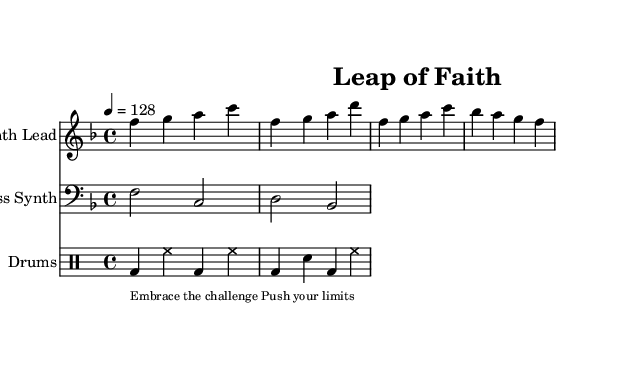What is the key signature of this piece? The key signature is F major, which has one flat (B flat).
Answer: F major What is the time signature used in this sheet music? The time signature is indicated at the beginning of the score as 4/4, meaning there are four beats per measure.
Answer: 4/4 What is the tempo marking for the composition? The tempo marking is found at the start with the indication "4 = 128", which instructs the performer to play at a speed of 128 beats per minute.
Answer: 128 How many measures are in the Synth Lead part shown? Counting the number of vertical lines (bar lines) after each group of notes, there are four measures in the Synth Lead part provided.
Answer: Four measures What dynamic is indicated in the score for the Synth Lead? There is no specific dynamic marking indicated for the Synth Lead, so it defaults to a moderate dynamic.
Answer: None indicated What type of drum pattern does the drum machine play primarily in this piece? The drum pattern shows a regular alternating pattern of bass drum and hi-hat, signifying a common electronic dance music structure with consistent beats.
Answer: Alternating bass and hi-hat pattern What thematic message is conveyed through the lyrics? The lyrics convey messages of resilience and motivation with phrases like "Embrace the challenge" and "Push your limits."
Answer: Resilience and motivation 